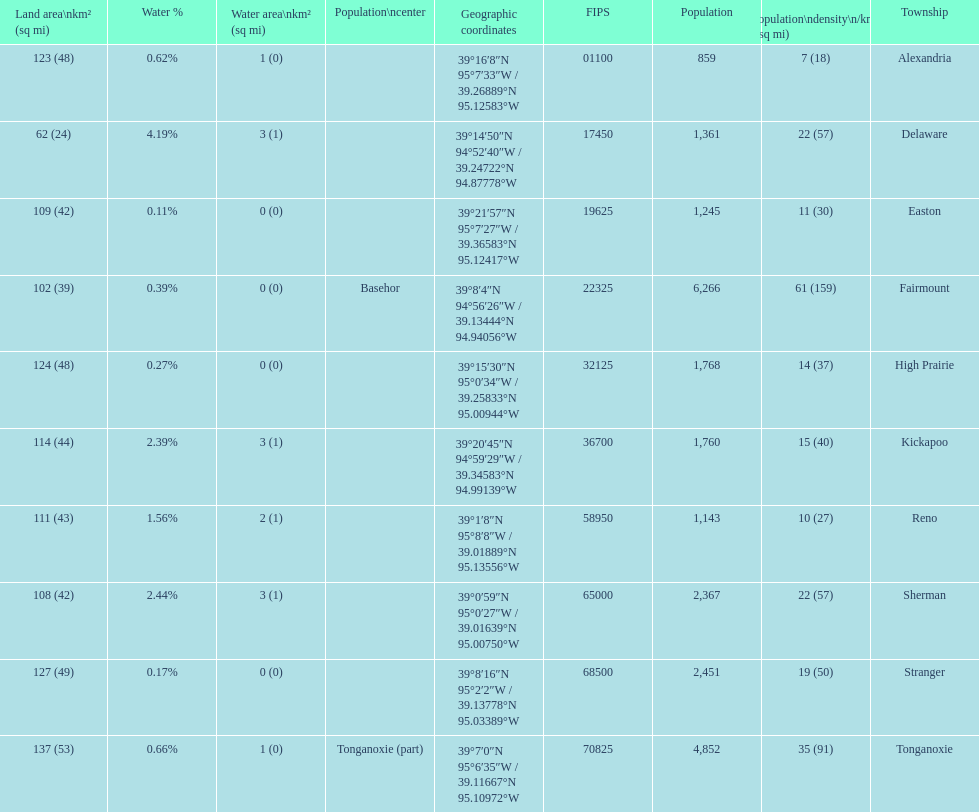Which township has the least land area? Delaware. 